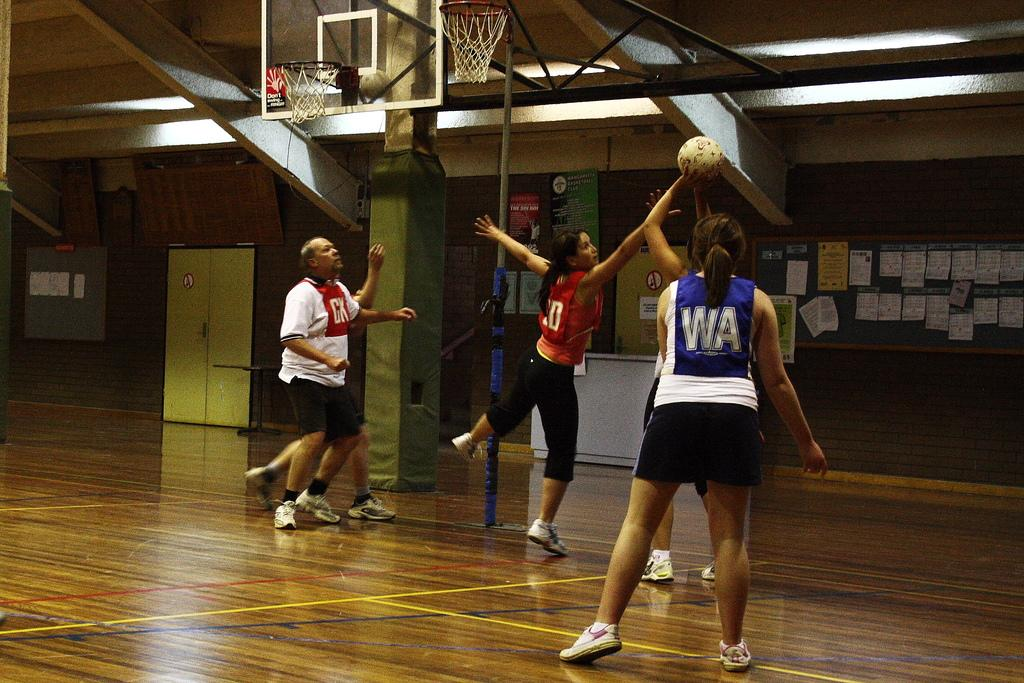<image>
Summarize the visual content of the image. Player number 10 in red jumps up to block a basketball shot by an opposing player. 